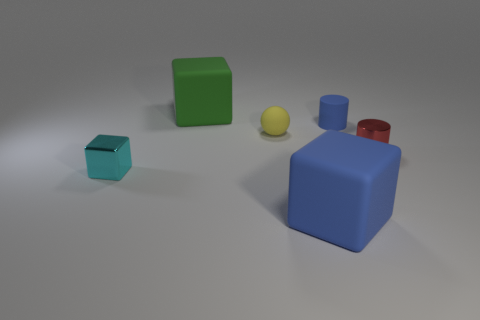Add 4 big green cubes. How many objects exist? 10 Subtract all cylinders. How many objects are left? 4 Add 4 small yellow matte things. How many small yellow matte things are left? 5 Add 5 yellow rubber things. How many yellow rubber things exist? 6 Subtract 0 green spheres. How many objects are left? 6 Subtract all yellow rubber balls. Subtract all cyan blocks. How many objects are left? 4 